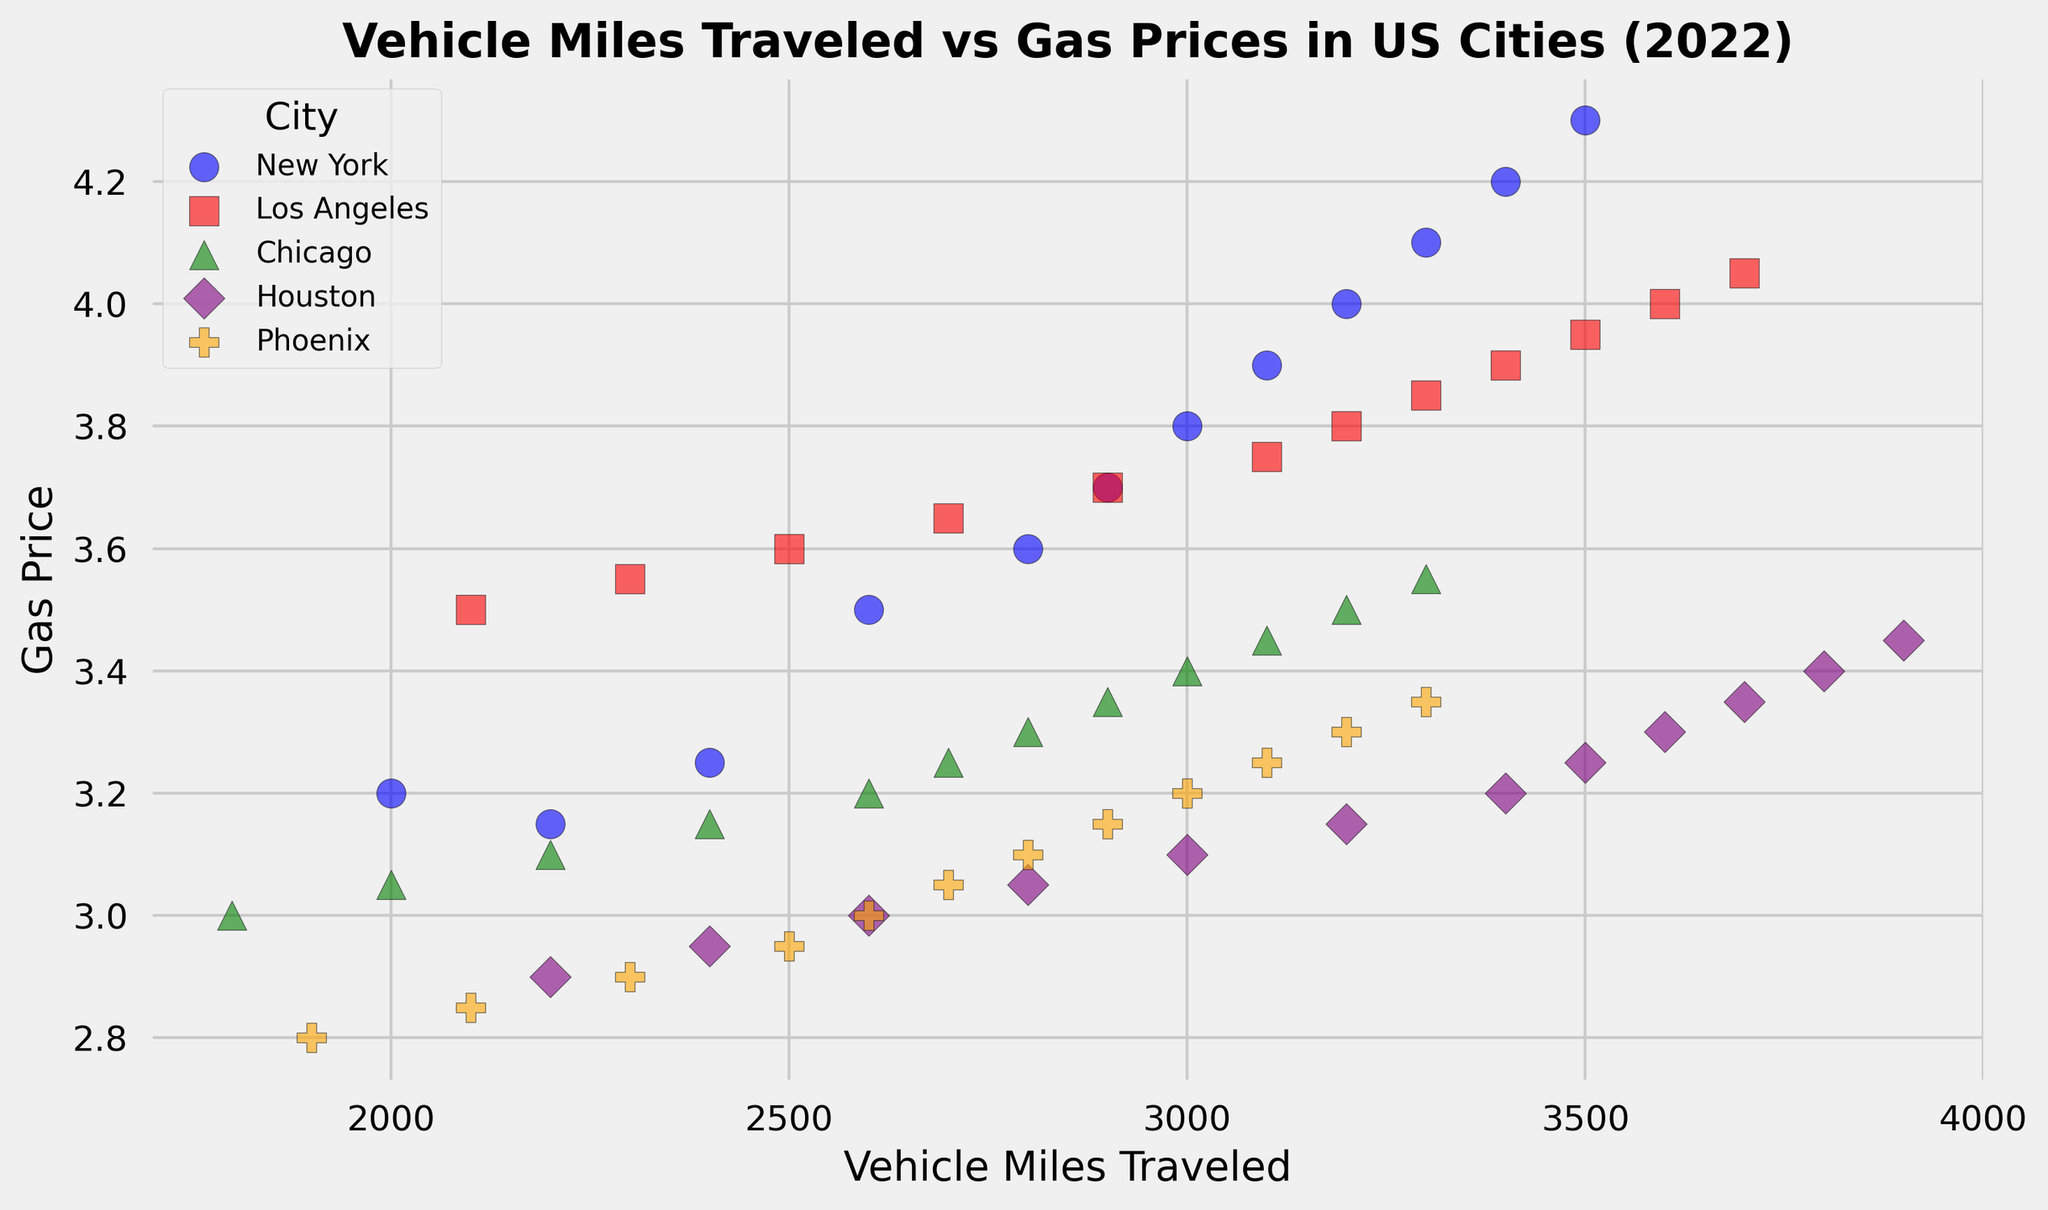What is the general trend between Vehicle Miles Traveled and Gas Prices in New York? In New York, as the Vehicle Miles Traveled increases, the Gas Prices also increase. This suggests a positive correlation between Vehicle Miles Traveled and Gas Prices.
Answer: Positive correlation Which city has the highest Vehicle Miles Traveled in December 2022? Looking at the scatter plot, Houston has the highest Vehicle Miles Traveled in December 2022 with a value of 3900.
Answer: Houston Among the cities compared, in which one is the difference between the highest and lowest Gas Prices the largest? Los Angeles shows the largest difference between the highest and lowest Gas Prices. Gas Prices increase from 3.50 in January to 4.05 in December, a difference of 0.55.
Answer: Los Angeles Which city has the most distinct marker shape on the scatter plot, and what is it? The distinct marker shape in the plot corresponding to Phoenix is a pentagon (shown as 'P').
Answer: Phoenix Compare Chicago and Phoenix in terms of Vehicle Miles Traveled in January 2022. Which city has greater Vehicle Miles Traveled? Chicago has a lower Vehicle Miles Traveled (1800) compared to Phoenix (1900) in January 2022.
Answer: Phoenix What is the average Gas Price for New York in the given data? The Gas Prices for New York are given for each month in 2022. Summing up the Gas Prices (3.20 + 3.15 + 3.25 + 3.50 + 3.60 + 3.70 + 3.80 + 3.90 + 4.00 + 4.10 + 4.20 + 4.30) gives 44.70. Dividing by 12 months provides an average Gas Price of 3.73.
Answer: 3.73 Which city shows the highest increase in Vehicle Miles Traveled from January to December 2022, and what is the magnitude of this increase? To find the highest increase, we look at the difference in Vehicle Miles Traveled for each city between January and December. Houston increases from 2200 to 3900, an increase of 1700. This is the highest increase among the cities.
Answer: 1700 What is the color used to represent Los Angeles on the scatter plot? Los Angeles is represented by the color red on the scatter plot.
Answer: Red How does the Gas Price in Houston in April 2022 compare to the Gas Price in Phoenix in April 2022? In April 2022, the Gas Price in Houston is 3.05 while in Phoenix it is 2.95. Thus, Houston has a higher Gas Price than Phoenix by 0.10.
Answer: Higher by 0.10 